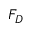<formula> <loc_0><loc_0><loc_500><loc_500>F _ { D }</formula> 